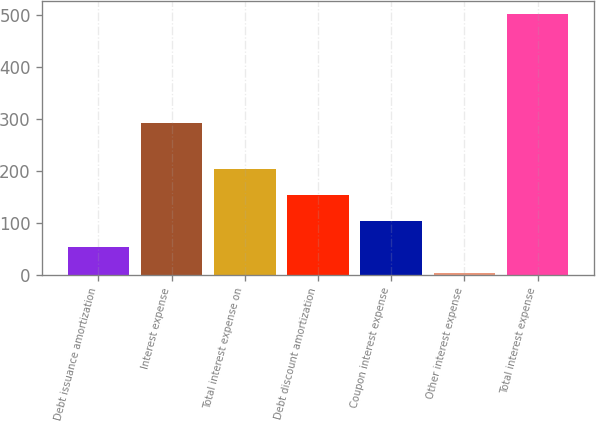<chart> <loc_0><loc_0><loc_500><loc_500><bar_chart><fcel>Debt issuance amortization<fcel>Interest expense<fcel>Total interest expense on<fcel>Debt discount amortization<fcel>Coupon interest expense<fcel>Other interest expense<fcel>Total interest expense<nl><fcel>52.9<fcel>291.8<fcel>202.9<fcel>152.9<fcel>102.9<fcel>2.9<fcel>502.9<nl></chart> 